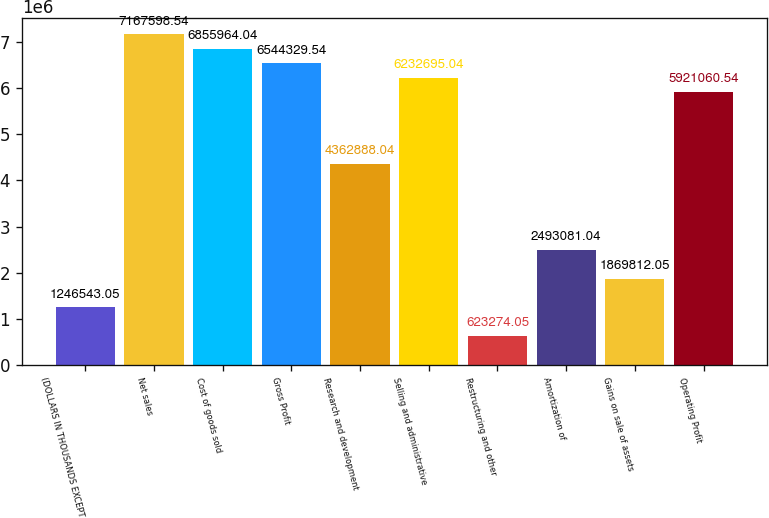Convert chart. <chart><loc_0><loc_0><loc_500><loc_500><bar_chart><fcel>(DOLLARS IN THOUSANDS EXCEPT<fcel>Net sales<fcel>Cost of goods sold<fcel>Gross Profit<fcel>Research and development<fcel>Selling and administrative<fcel>Restructuring and other<fcel>Amortization of<fcel>Gains on sale of assets<fcel>Operating Profit<nl><fcel>1.24654e+06<fcel>7.1676e+06<fcel>6.85596e+06<fcel>6.54433e+06<fcel>4.36289e+06<fcel>6.2327e+06<fcel>623274<fcel>2.49308e+06<fcel>1.86981e+06<fcel>5.92106e+06<nl></chart> 